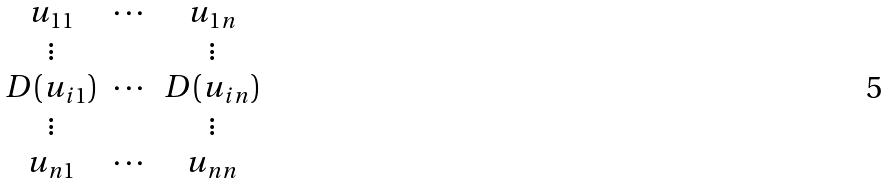<formula> <loc_0><loc_0><loc_500><loc_500>\begin{matrix} u _ { 1 1 } & \cdots & u _ { 1 n } \\ \vdots & & \vdots \\ D ( u _ { i 1 } ) & \cdots & D ( u _ { i n } ) \\ \vdots & & \vdots \\ u _ { n 1 } & \cdots & u _ { n n } \end{matrix}</formula> 